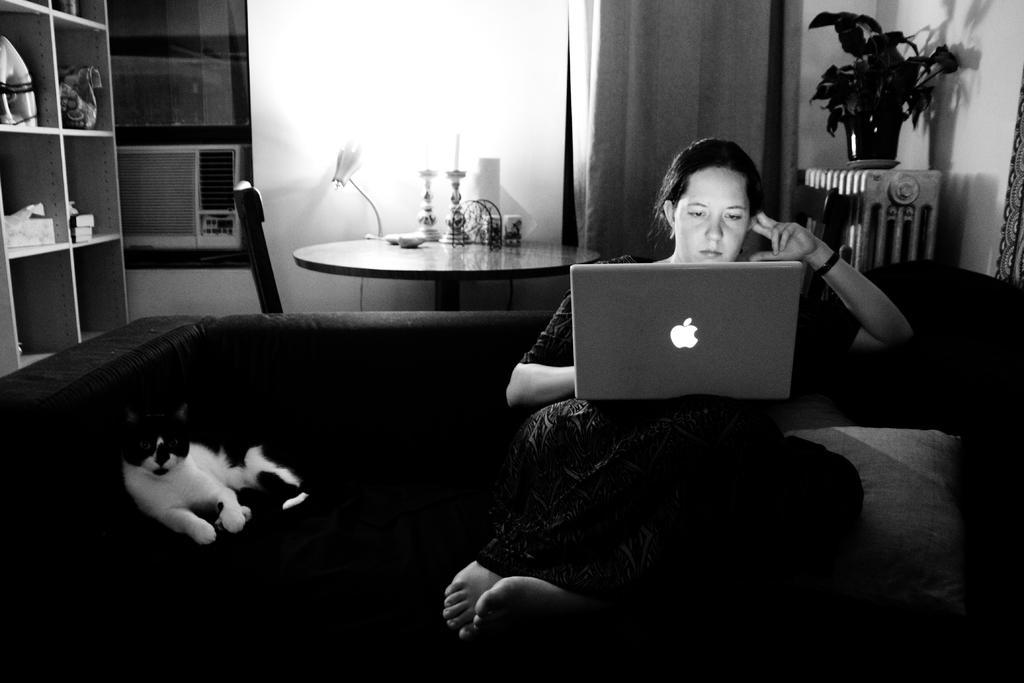Can you describe this image briefly? In this picture there is a woman who is sitting on the couch and she is looking in the laptop, beside her there is a cat who is the laying on the pillow. In the back I can see the tissue paper, plate and other objects on the table. On the left there is a window AC which is placed on the window, beside that I can see the wooden shelves. In the top right I can see the plant and pot on the rack. 